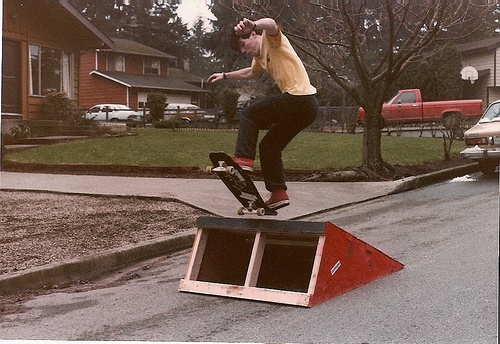Describe the objects in this image and their specific colors. I can see people in white, black, maroon, and gray tones, truck in white, maroon, brown, and lightpink tones, car in white, lightgray, black, gray, and maroon tones, skateboard in white, black, gray, and maroon tones, and car in white, lightgray, darkgray, gray, and maroon tones in this image. 